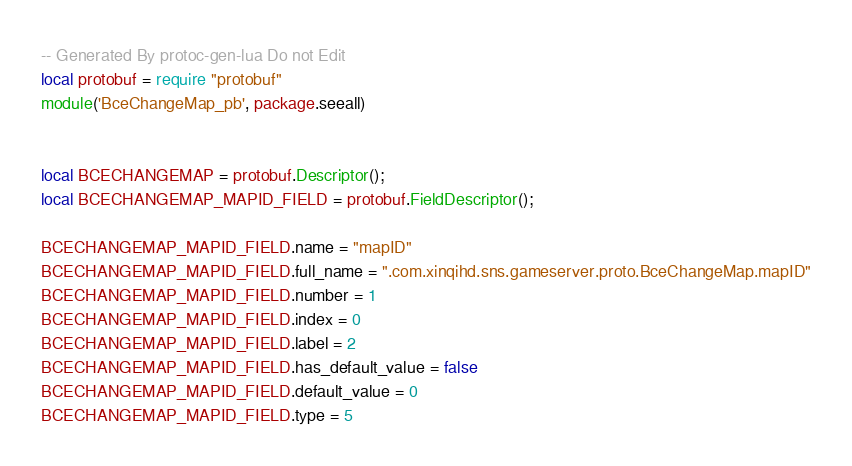<code> <loc_0><loc_0><loc_500><loc_500><_Lua_>-- Generated By protoc-gen-lua Do not Edit
local protobuf = require "protobuf"
module('BceChangeMap_pb', package.seeall)


local BCECHANGEMAP = protobuf.Descriptor();
local BCECHANGEMAP_MAPID_FIELD = protobuf.FieldDescriptor();

BCECHANGEMAP_MAPID_FIELD.name = "mapID"
BCECHANGEMAP_MAPID_FIELD.full_name = ".com.xinqihd.sns.gameserver.proto.BceChangeMap.mapID"
BCECHANGEMAP_MAPID_FIELD.number = 1
BCECHANGEMAP_MAPID_FIELD.index = 0
BCECHANGEMAP_MAPID_FIELD.label = 2
BCECHANGEMAP_MAPID_FIELD.has_default_value = false
BCECHANGEMAP_MAPID_FIELD.default_value = 0
BCECHANGEMAP_MAPID_FIELD.type = 5</code> 